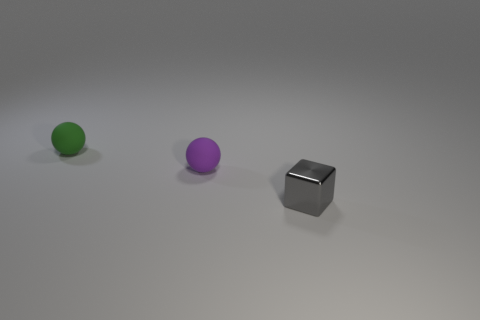Add 3 yellow cylinders. How many objects exist? 6 Subtract all cubes. How many objects are left? 2 Subtract all purple rubber spheres. Subtract all tiny rubber cubes. How many objects are left? 2 Add 2 tiny shiny cubes. How many tiny shiny cubes are left? 3 Add 1 small purple matte objects. How many small purple matte objects exist? 2 Subtract 1 green balls. How many objects are left? 2 